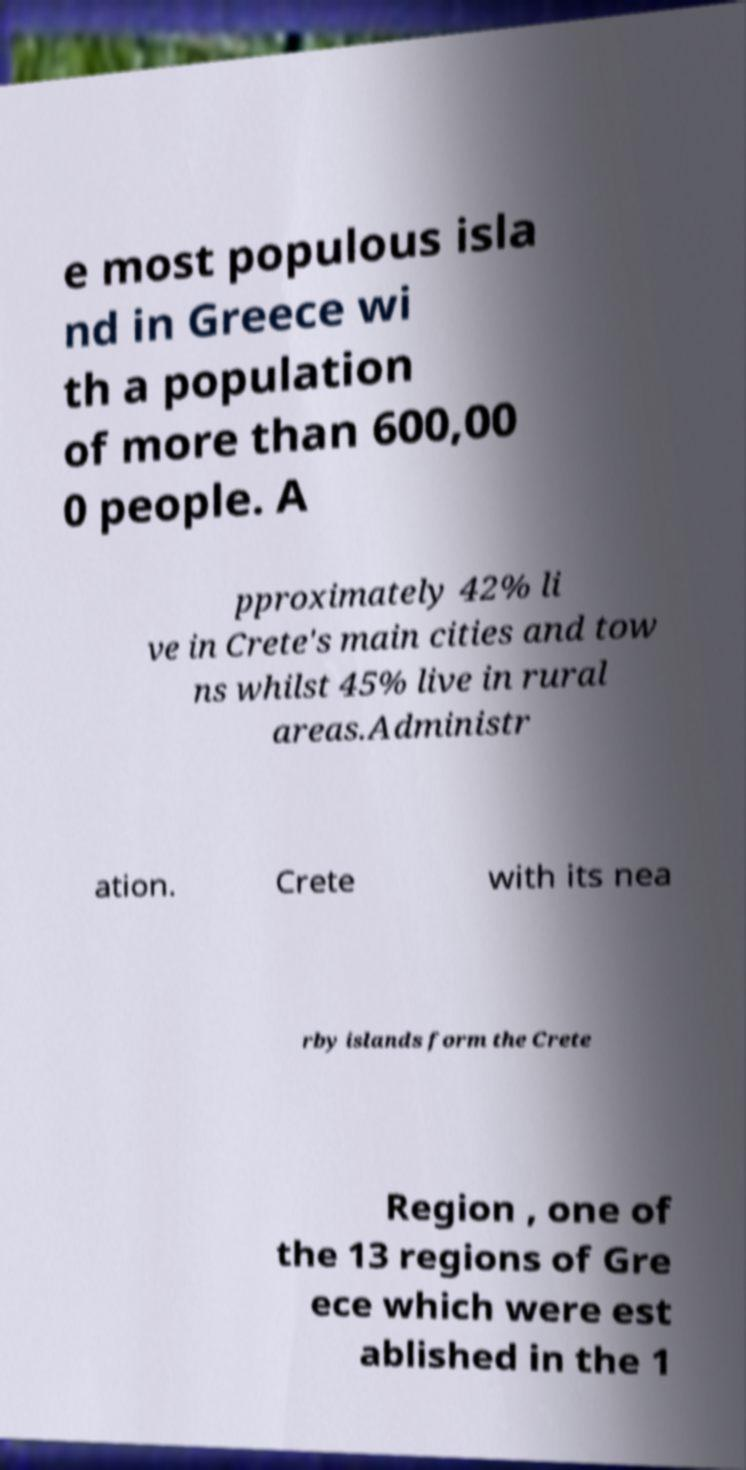For documentation purposes, I need the text within this image transcribed. Could you provide that? e most populous isla nd in Greece wi th a population of more than 600,00 0 people. A pproximately 42% li ve in Crete's main cities and tow ns whilst 45% live in rural areas.Administr ation. Crete with its nea rby islands form the Crete Region , one of the 13 regions of Gre ece which were est ablished in the 1 